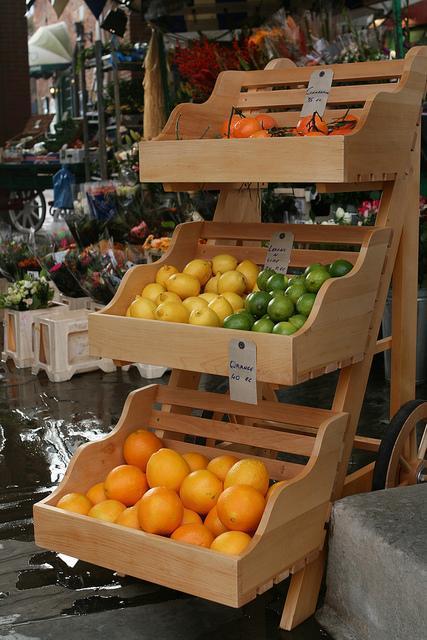How many different levels of shelves are there?
Give a very brief answer. 3. 